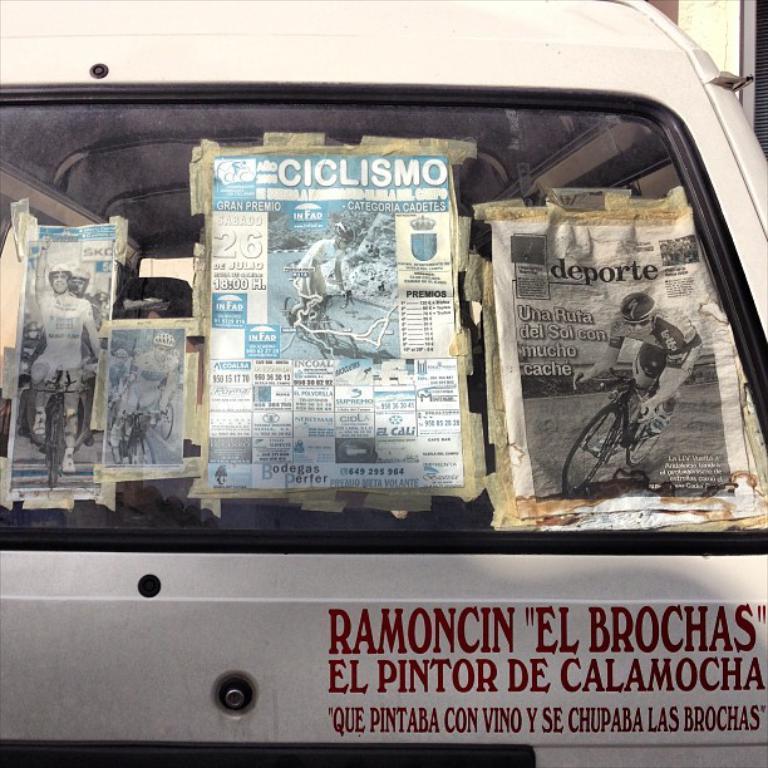In one or two sentences, can you explain what this image depicts? In this image I can see there is a vehicle. And there is some text written on it. And there are papers with image and text written on it and that paper pasted to the vehicle. 